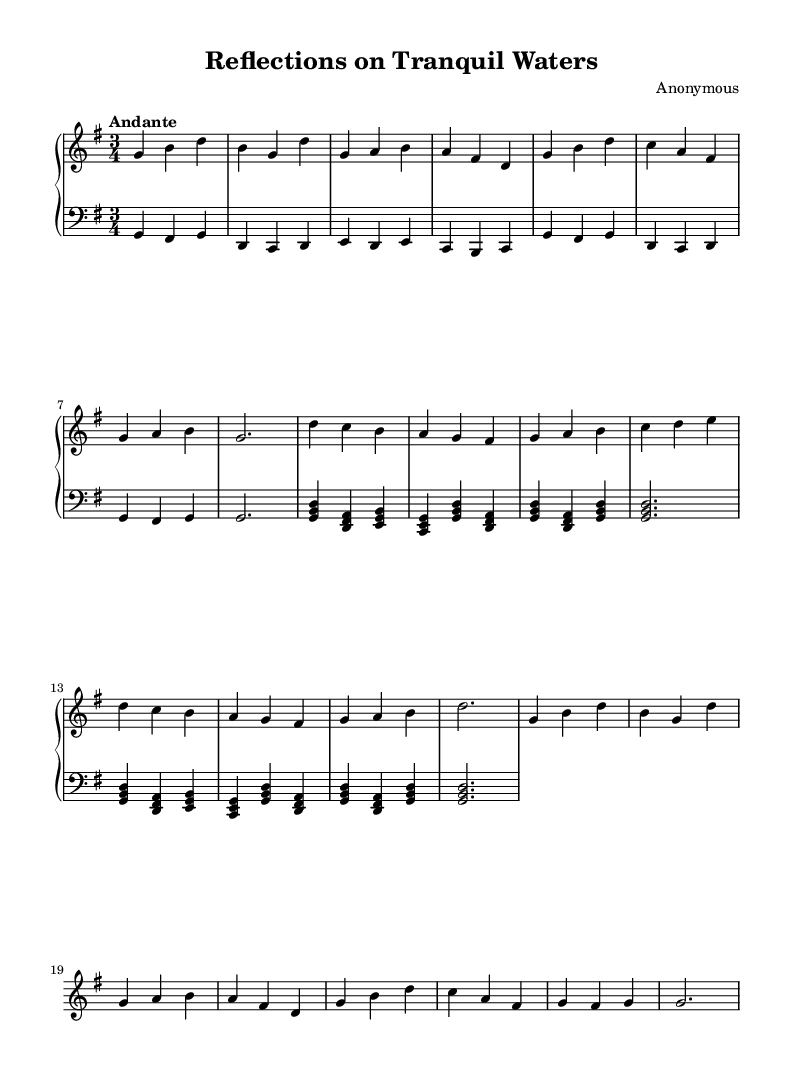What is the key signature of this music? The key signature is indicated on the staff at the beginning of the piece and shows one sharp (F#), indicating that the piece is in G major.
Answer: G major What is the time signature of this music? The time signature is shown as a fraction-like symbol at the beginning of the piece, which represents the number of beats in a measure. It is written as 3/4, indicating three beats per measure.
Answer: 3/4 What is the tempo marking? The tempo marking is noted at the beginning of the score as "Andante," which suggests a moderately slow pace.
Answer: Andante How many sections are there in the piece? By examining the structure indicated in the music, there are three sections labeled A, B, and A’. Therefore, the total sections is the count of A, B, and A', which gives us three sections.
Answer: 3 What musical technique is used in the left hand part? The left hand part predominantly uses arpeggiated chords, which is characteristic of the Baroque style and helps to provide harmonic support beneath the melody.
Answer: Arpeggiated chords What type of musical piece is this? Given the style, instrumentation, and the characteristics present, this piece can be classified as a harpsichord composition typical of the Baroque period, focusing on expressing calm and serene themes.
Answer: Harpsichord composition What is the overall mood that this piece conveys? The piece’s gentle tempo, smooth melodic lines, and harmonic richness contribute to an overall mood of serenity, evoking tranquil lake scenes, which is supported by the title.
Answer: Serene 